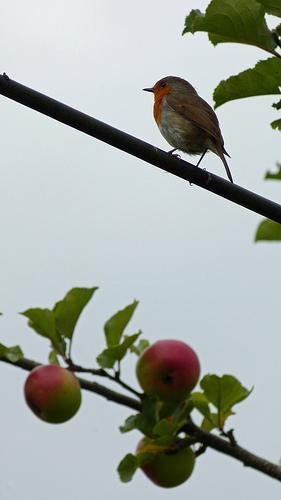How many apples are there?
Give a very brief answer. 3. 